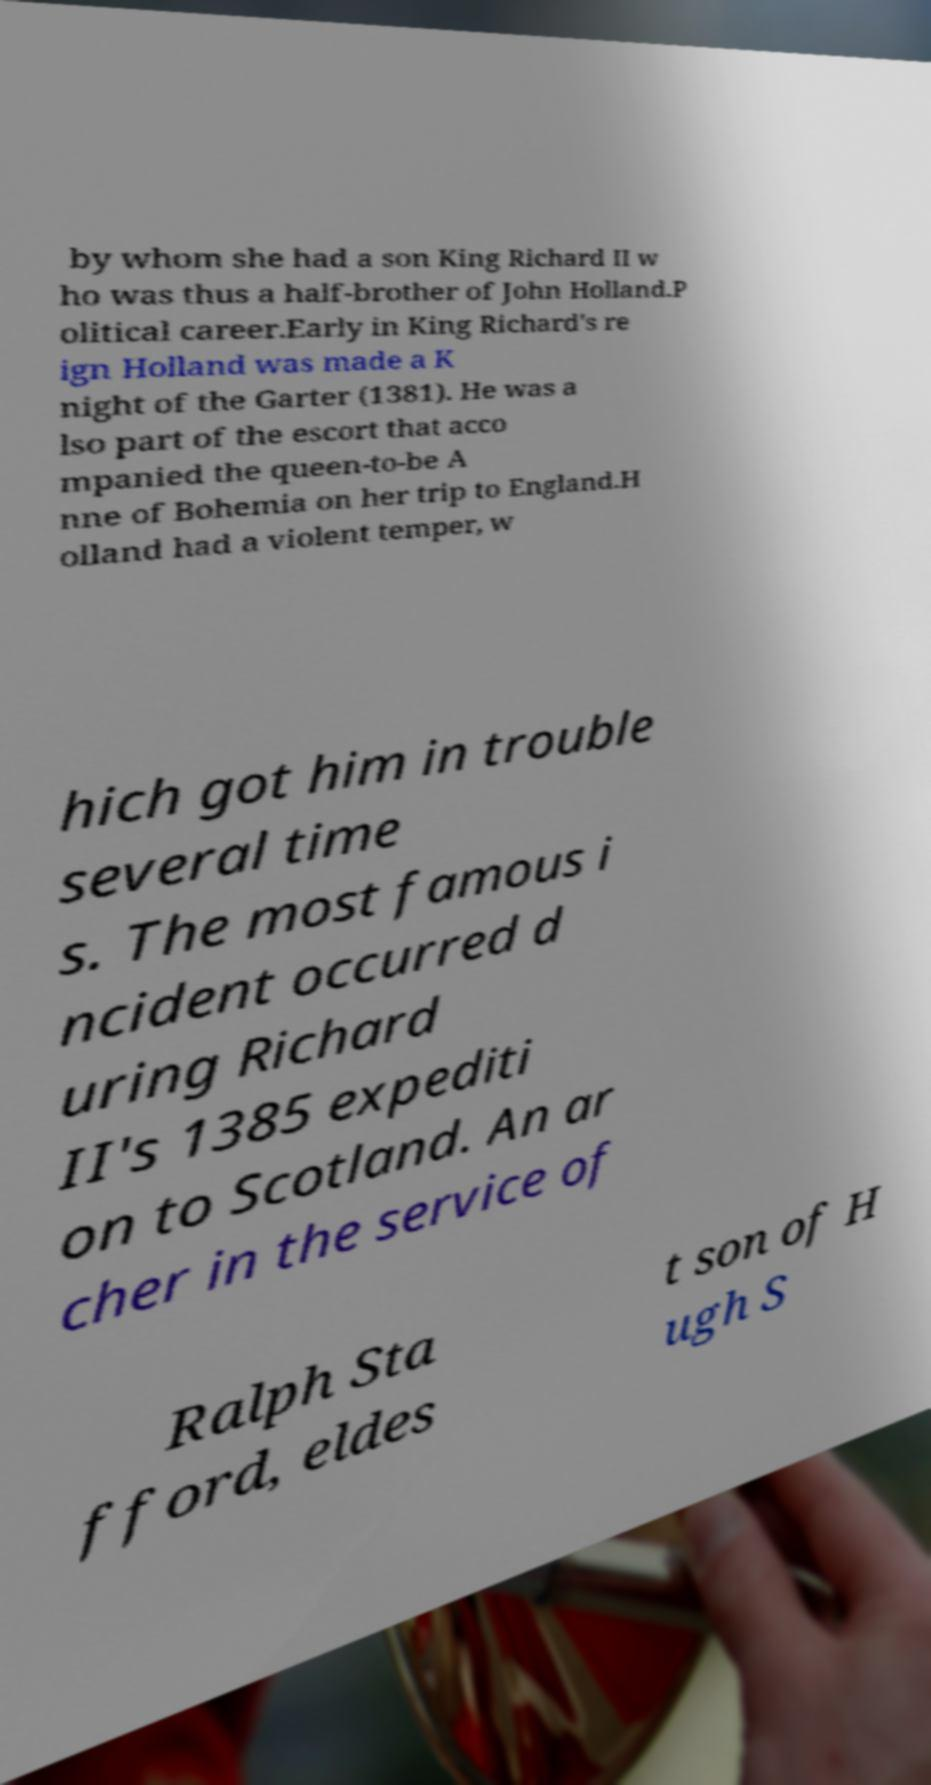Can you read and provide the text displayed in the image?This photo seems to have some interesting text. Can you extract and type it out for me? by whom she had a son King Richard II w ho was thus a half-brother of John Holland.P olitical career.Early in King Richard's re ign Holland was made a K night of the Garter (1381). He was a lso part of the escort that acco mpanied the queen-to-be A nne of Bohemia on her trip to England.H olland had a violent temper, w hich got him in trouble several time s. The most famous i ncident occurred d uring Richard II's 1385 expediti on to Scotland. An ar cher in the service of Ralph Sta fford, eldes t son of H ugh S 